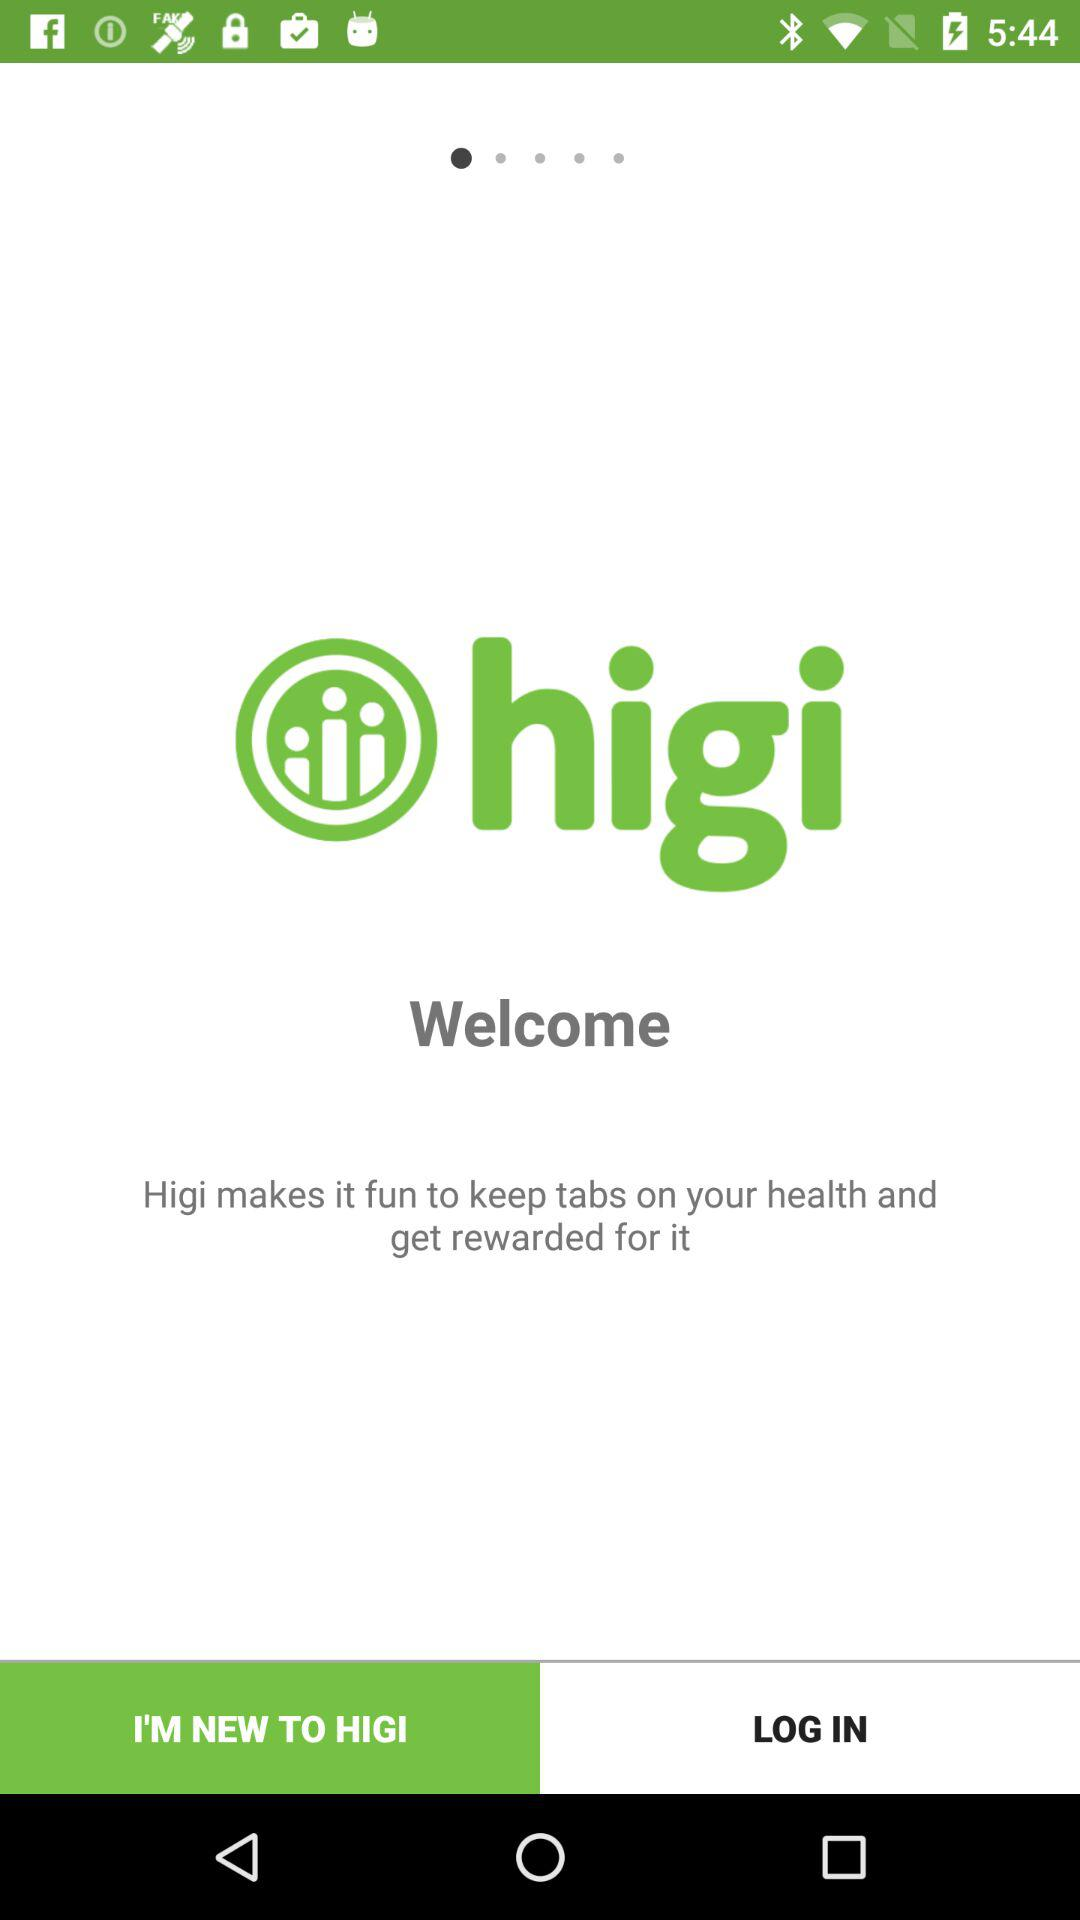What is the name of the application? The name of the application is "higi". 